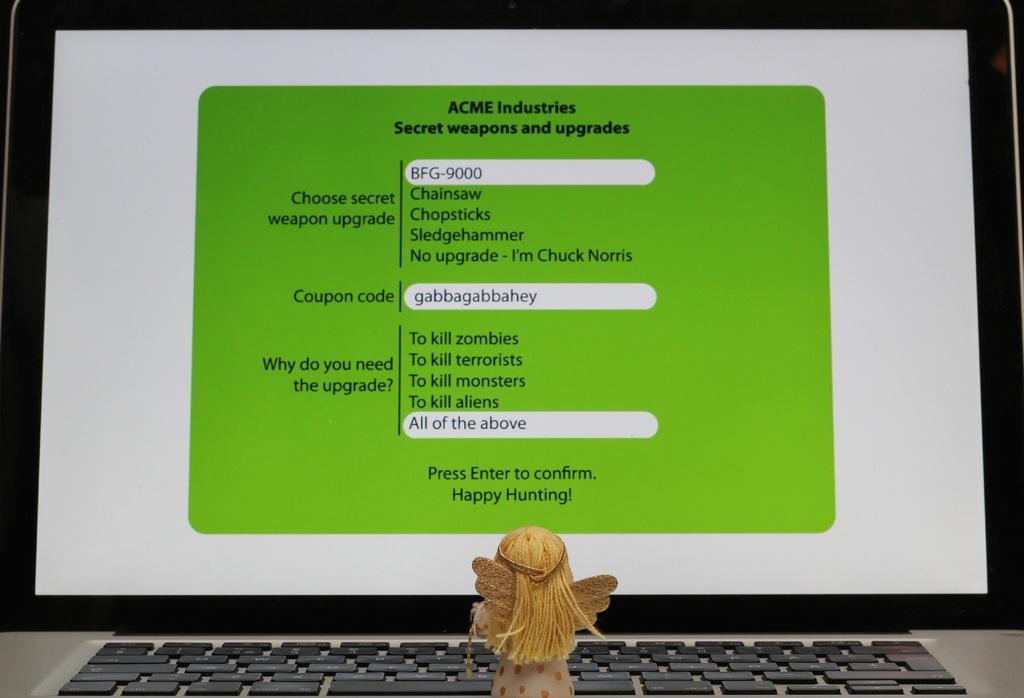Which company is issuing the test?
Offer a very short reply. Acme industries. Who are you if you don't need a weapon upgrade?
Provide a short and direct response. Chuck norris. 